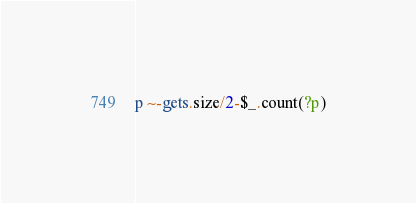<code> <loc_0><loc_0><loc_500><loc_500><_Ruby_>p ~-gets.size/2-$_.count(?p)</code> 